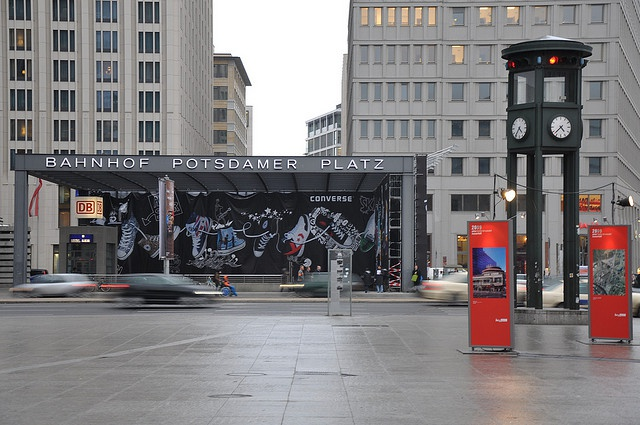Describe the objects in this image and their specific colors. I can see car in gray, black, and darkgray tones, car in gray, darkgray, black, and lightgray tones, car in gray, darkgray, lightgray, and tan tones, car in gray, darkgray, lightgray, and black tones, and car in gray, black, and purple tones in this image. 